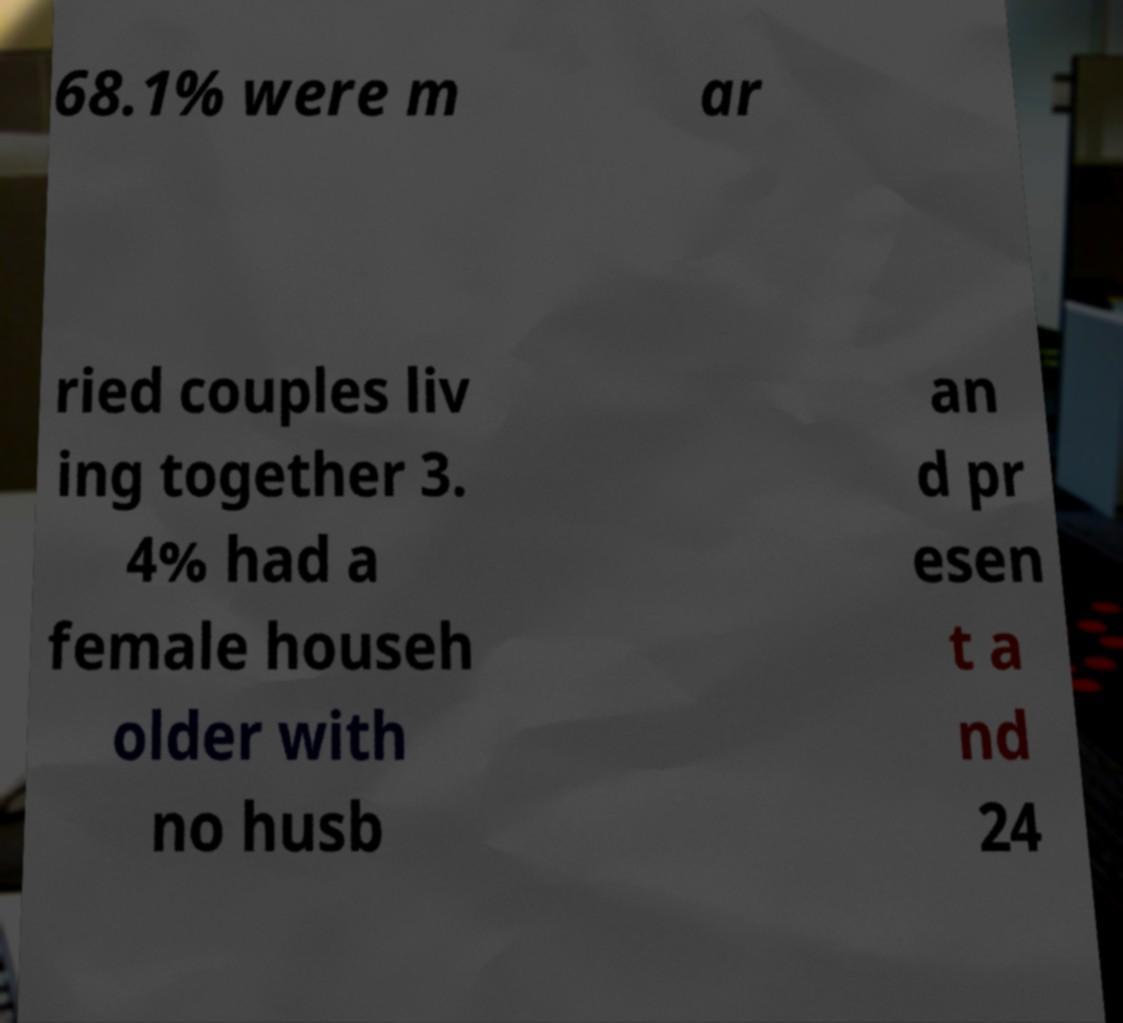Can you read and provide the text displayed in the image?This photo seems to have some interesting text. Can you extract and type it out for me? 68.1% were m ar ried couples liv ing together 3. 4% had a female househ older with no husb an d pr esen t a nd 24 